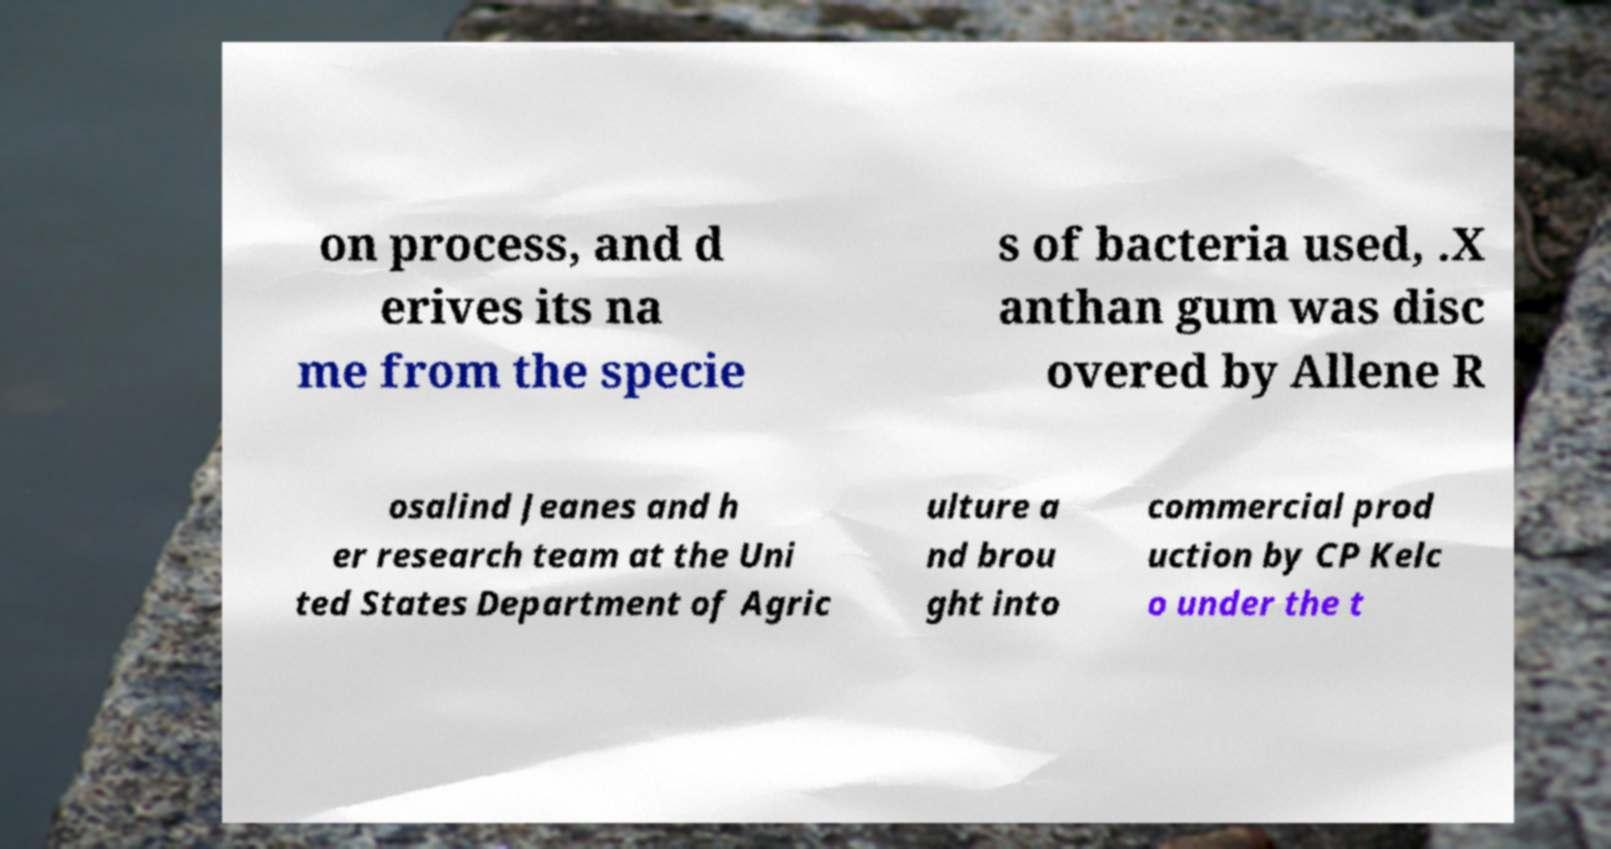Please read and relay the text visible in this image. What does it say? on process, and d erives its na me from the specie s of bacteria used, .X anthan gum was disc overed by Allene R osalind Jeanes and h er research team at the Uni ted States Department of Agric ulture a nd brou ght into commercial prod uction by CP Kelc o under the t 